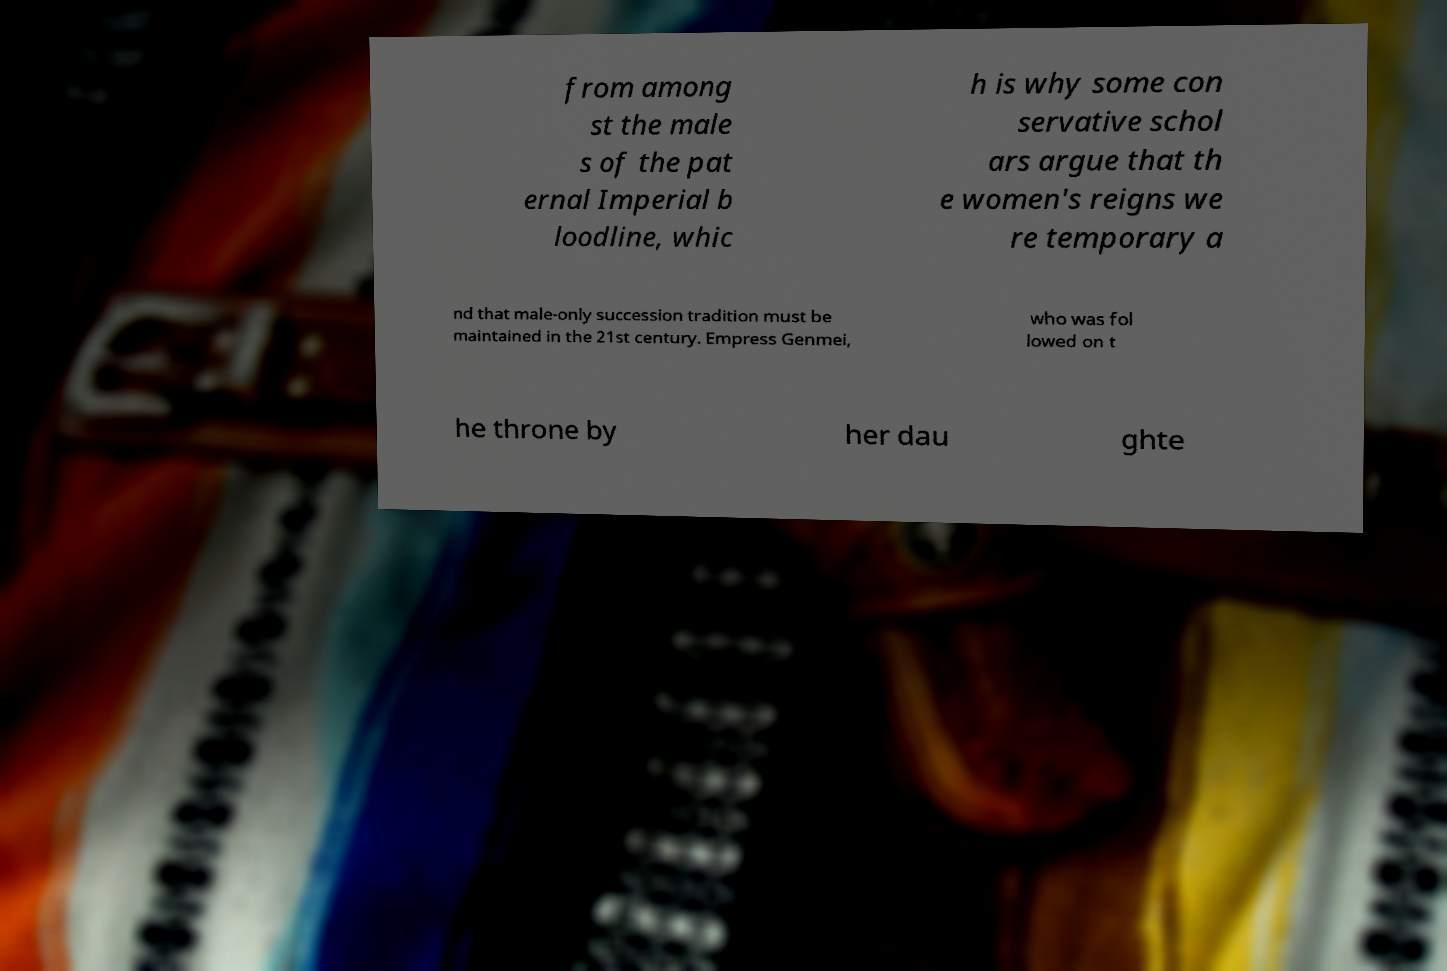Please read and relay the text visible in this image. What does it say? from among st the male s of the pat ernal Imperial b loodline, whic h is why some con servative schol ars argue that th e women's reigns we re temporary a nd that male-only succession tradition must be maintained in the 21st century. Empress Genmei, who was fol lowed on t he throne by her dau ghte 